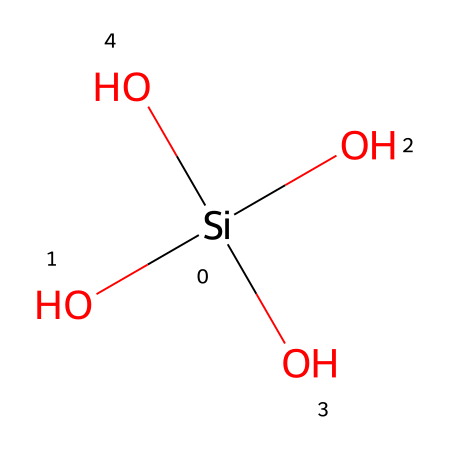What is the central atom in this chemical structure? The central atom is silicon, as indicated by the 'Si' in the SMILES representation.
Answer: silicon How many oxygen atoms are present in this structure? The structure shows four oxygen atoms attached to the silicon atom, as represented by four 'O' in the SMILES.
Answer: four What is the primary use of this chemical in ceramics? The primary use of silica in ceramics is for creating glass and porcelain materials, which benefit from its high thermal resistance and strength.
Answer: glass and porcelain Does this chemical have acidic or basic properties? Silica is generally considered to be neutral, lacking strong acidic or basic characteristics.
Answer: neutral What type of bond connects silicon to oxygen in this structure? The bond between silicon and oxygen in silica is a covalent bond, as these atoms share electrons to achieve stability.
Answer: covalent bond How many total atoms are in the chemical structure? There are five atoms in total: one silicon and four oxygen atoms.
Answer: five What characteristic of silica contributes to its durability in ceramics? The strong covalent bonds between the silicon and oxygen atoms provide structural integrity, making silica durable in ceramics.
Answer: strong covalent bonds 